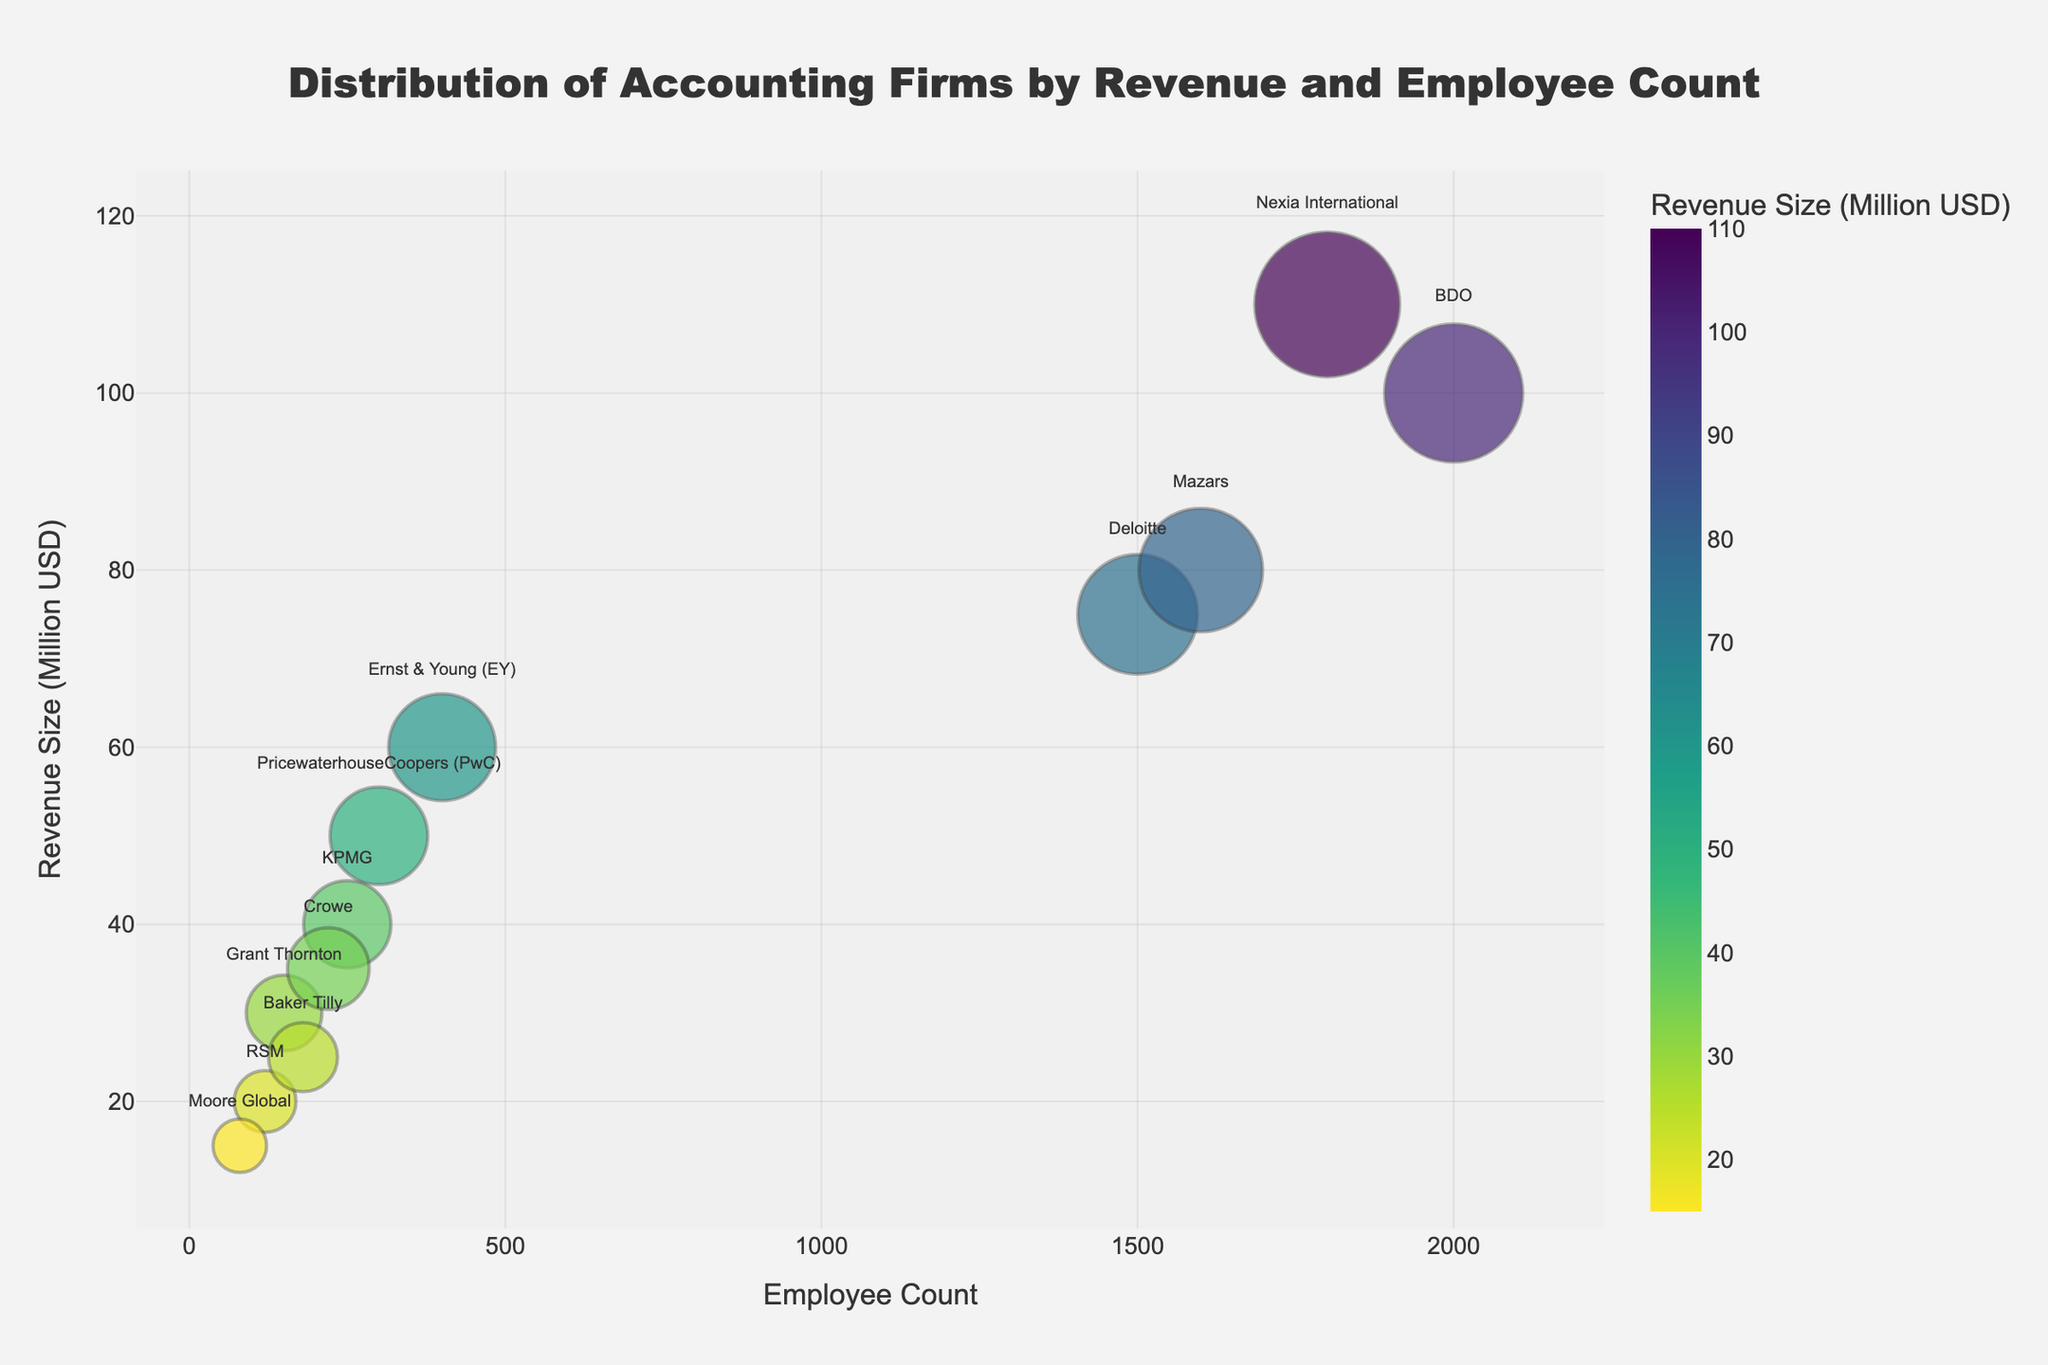What's the title of the chart? The title is visible at the top of the chart, centered. It reads: "Distribution of Accounting Firms by Revenue and Employee Count".
Answer: Distribution of Accounting Firms by Revenue and Employee Count How many accounting firms are represented in the chart? Each bubble represents an accounting firm. Counting all the bubbles on the chart will give the number of accounting firms.
Answer: 12 Which accounting firm has the highest revenue size? Looking at the y-axis, which shows the revenue size in million USD, the highest point is at $110 million. The bubble at this point is labeled Nexia International.
Answer: Nexia International Which accounting firm has the lowest number of employees? The x-axis represents the employee count. The smallest value on the x-axis is 80. The bubble at this point is labeled Moore Global.
Answer: Moore Global Which firm has a revenue size of $80 million and what is its employee count? By looking at the y-axis for a revenue size of $80 million, we find a bubble labeled Mazars. We then look at its position on the x-axis to find its employee count, which is 1,600.
Answer: Mazars, 1,600 What is the average employee count of firms with revenue sizes above $50 million? First, identify firms with revenue sizes above $50 million (PwC, Deloitte, EY, BDO, Mazars, Nexia). Their employee counts are 300, 1500, 400, 2000, 1600, 1800 respectively. Summing these gives 7,600, and there are 6 firms. Calculating the average: 7600 ÷ 6 = 1,267.
Answer: 1,267 Which firm has the largest bubble size and what does it represent? The bubble size represents the revenue size metric. The largest bubble corresponds to the highest revenue size, which is $110 million for Nexia International.
Answer: Nexia International, $110 million Compare the employee count of KPMG and Crowe. Which one has more employees and by how much? KPMG has 250 employees, and Crowe has 220 employees. The difference between them is 250 - 220 = 30.
Answer: KPMG, 30 Identify the firm with the smallest revenue size and describe its bubble position on the chart. The smallest revenue size in the dataset is $15 million for Moore Global. Its bubble is at the lower left of the chart with 80 employees.
Answer: Moore Global, lower left What is the total revenue size for firms with less than 200 employees? Firms with less than 200 employees are Grant Thornton, RSM, Baker Tilly, and Moore Global. Their revenue sizes are 30, 20, 25, and 15 million respectively. Summing these: 30 + 20 + 25 + 15 = 90 million USD.
Answer: 90 million USD 